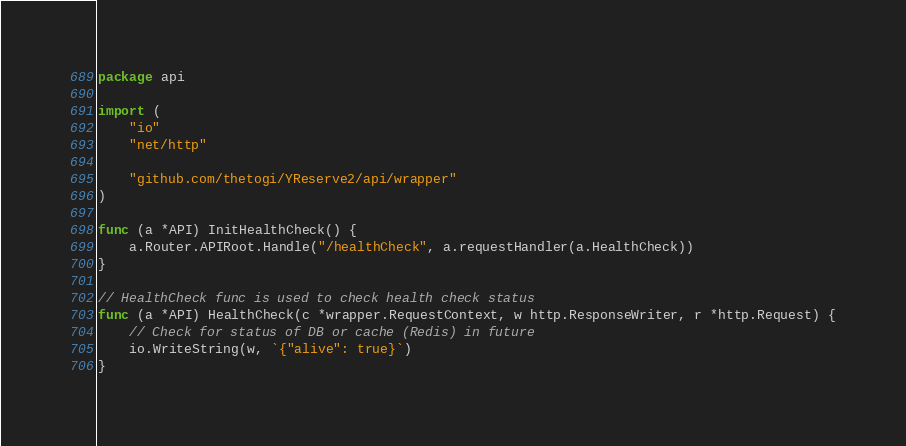<code> <loc_0><loc_0><loc_500><loc_500><_Go_>package api

import (
	"io"
	"net/http"

	"github.com/thetogi/YReserve2/api/wrapper"
)

func (a *API) InitHealthCheck() {
	a.Router.APIRoot.Handle("/healthCheck", a.requestHandler(a.HealthCheck))
}

// HealthCheck func is used to check health check status
func (a *API) HealthCheck(c *wrapper.RequestContext, w http.ResponseWriter, r *http.Request) {
	// Check for status of DB or cache (Redis) in future
	io.WriteString(w, `{"alive": true}`)
}
</code> 